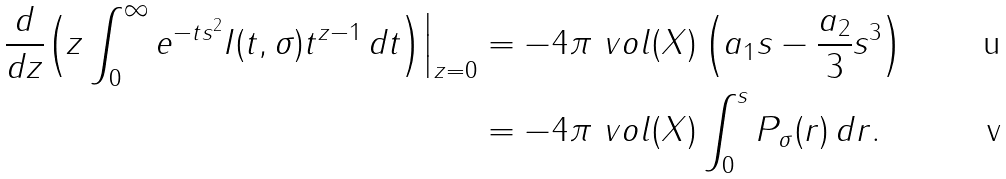Convert formula to latex. <formula><loc_0><loc_0><loc_500><loc_500>\frac { d } { d z } \Big ( z \int _ { 0 } ^ { \infty } e ^ { - t s ^ { 2 } } I ( t , \sigma ) t ^ { z - 1 } \, d t \Big ) \Big | _ { z = 0 } & = - 4 \pi \ v o l ( X ) \left ( a _ { 1 } s - \frac { a _ { 2 } } { 3 } s ^ { 3 } \right ) \\ & = - 4 \pi \ v o l ( X ) \int _ { 0 } ^ { s } P _ { \sigma } ( r ) \, d r .</formula> 